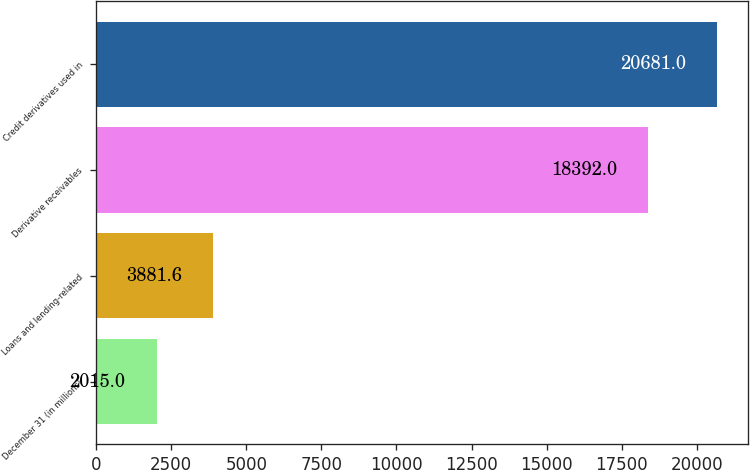<chart> <loc_0><loc_0><loc_500><loc_500><bar_chart><fcel>December 31 (in millions)<fcel>Loans and lending-related<fcel>Derivative receivables<fcel>Credit derivatives used in<nl><fcel>2015<fcel>3881.6<fcel>18392<fcel>20681<nl></chart> 